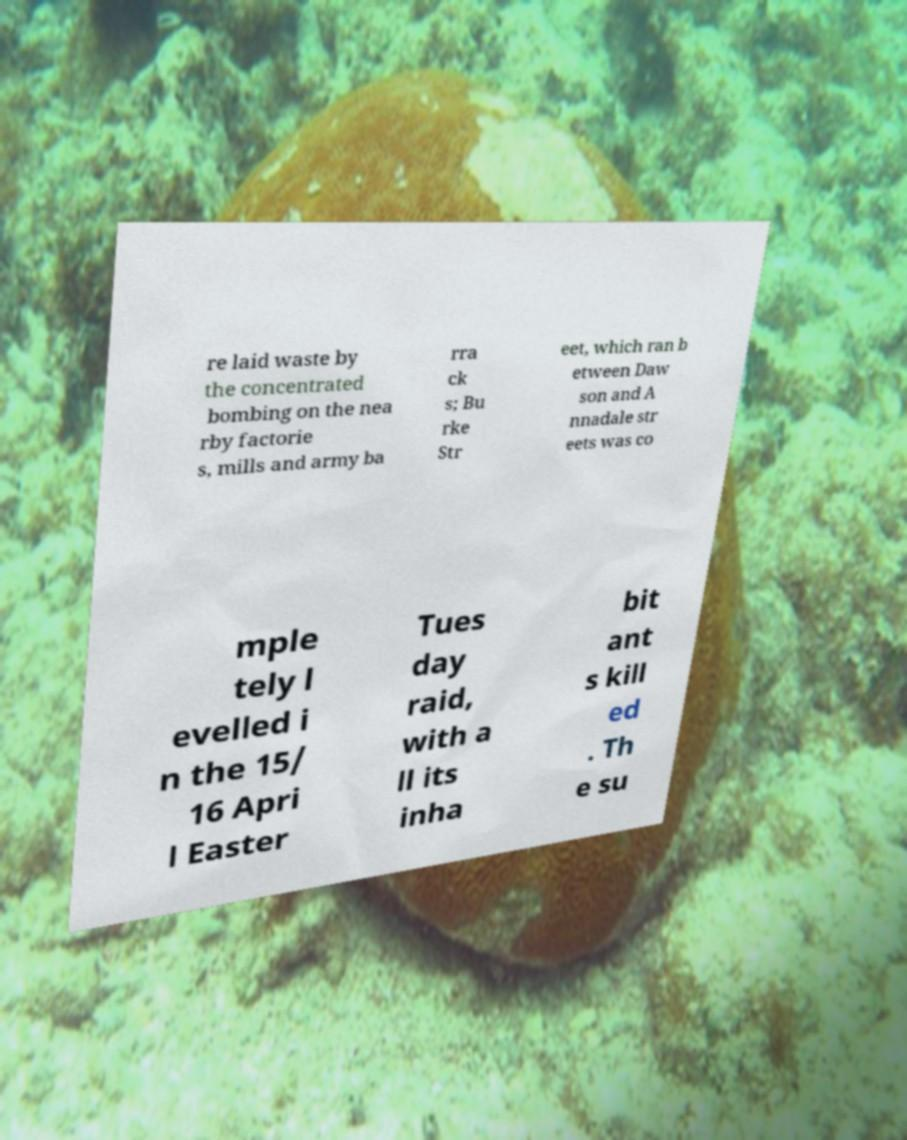Please read and relay the text visible in this image. What does it say? re laid waste by the concentrated bombing on the nea rby factorie s, mills and army ba rra ck s; Bu rke Str eet, which ran b etween Daw son and A nnadale str eets was co mple tely l evelled i n the 15/ 16 Apri l Easter Tues day raid, with a ll its inha bit ant s kill ed . Th e su 